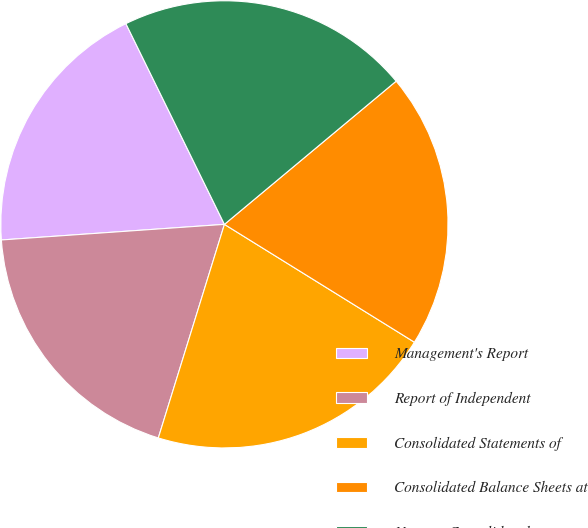<chart> <loc_0><loc_0><loc_500><loc_500><pie_chart><fcel>Management's Report<fcel>Report of Independent<fcel>Consolidated Statements of<fcel>Consolidated Balance Sheets at<fcel>Notes to Consolidated<nl><fcel>18.85%<fcel>19.11%<fcel>20.94%<fcel>19.9%<fcel>21.2%<nl></chart> 